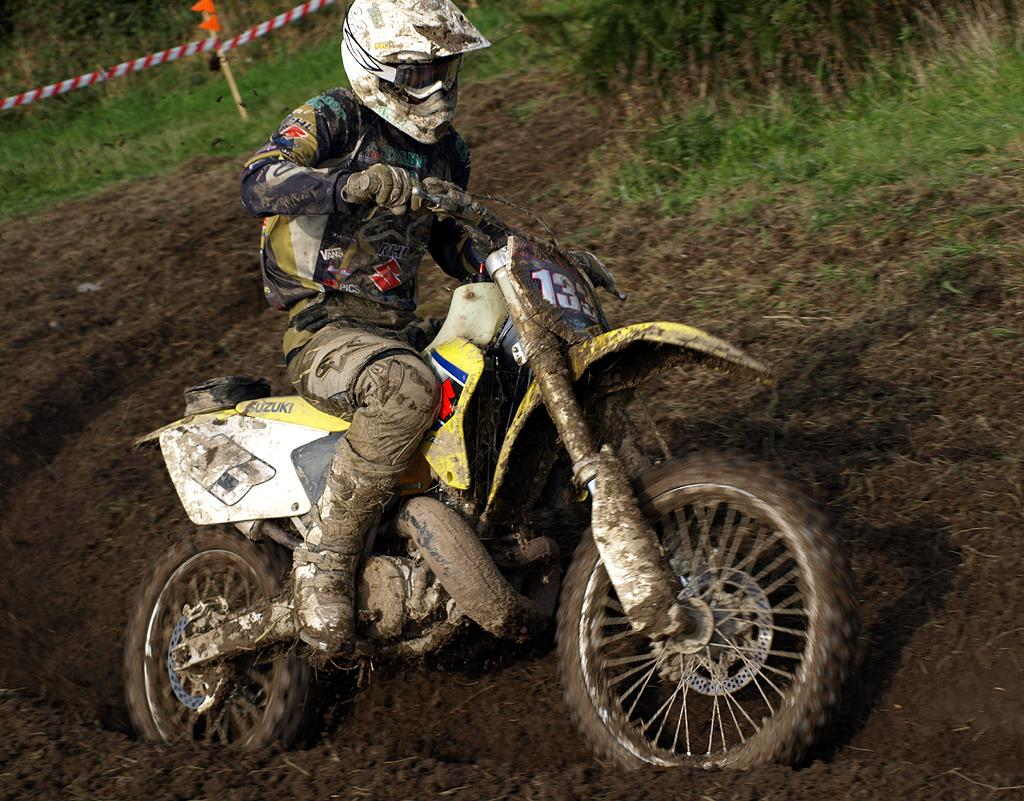What is the main subject of the image? There is a person in the image. What is the person doing in the image? The person is sitting on a bike. What can be seen in the background of the image? There is grass visible in the background of the image. What type of boot can be seen on the person's foot in the image? There is no boot visible on the person's foot in the image; they are sitting on a bike with their feet on the pedals. 